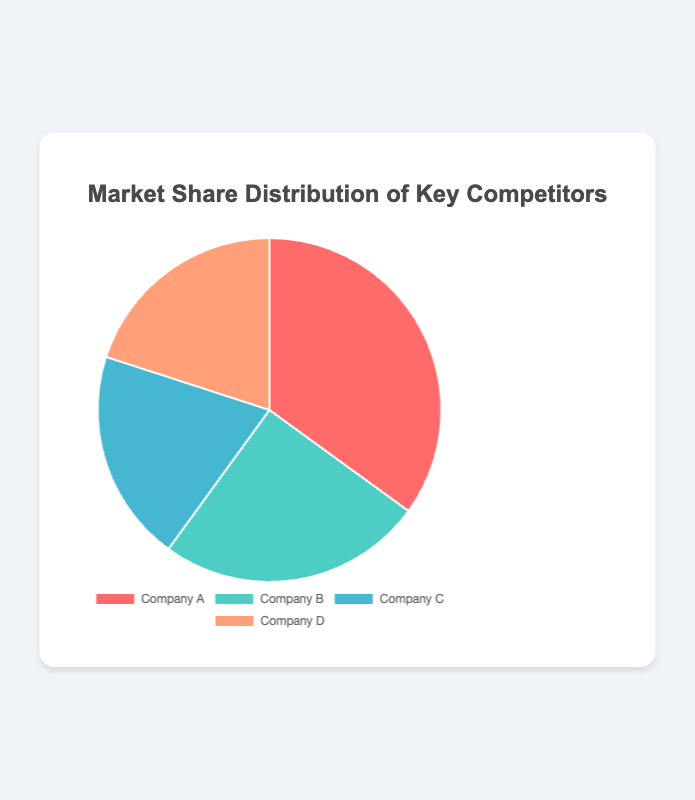what is the market share of Company A? By looking at the pie chart, we can see that the segment representing Company A is labeled with a market share percentage.
Answer: 35% Which company holds the smallest market share? Comparing the slices of the pie chart visually, we can see that Companies C and D have the smallest shares, both at 20%.
Answer: Company C and Company D What is the combined market share of Companies C and D? Adding the market shares of Companies C (20%) and D (20%) together to get the total. 20 + 20 = 40
Answer: 40% How does Company B's market share compare to Company A’s? By examining the pie chart, Company A has a 35% market share, while Company B has a 25% market share. Comparing these two, Company B's share is smaller.
Answer: Company A's share is larger by 10% Which company represents the largest segment of the pie? Looking at the visual representation and their labels, Company A, with a 35% share, occupies the largest segment.
Answer: Company A How much larger is Company A's market share compared to Company D's? Subtract Company D's market share (20%) from Company A's market share (35%). 35 - 20 = 15
Answer: 15% What is the average market share of all companies? To find the average, add up the market shares of all companies and divide by the number of companies. (35 + 25 + 20 + 20)/4 = 100/4 = 25
Answer: 25% If Company A and Company B merged, what would their combined market share be? Sum the market shares of Company A (35%) and Company B (25%). 35 + 25 = 60
Answer: 60% What color represents Company C? By referring to the visual attributes of the pie chart, the segment for Company C is in blue.
Answer: Blue Which two companies have equal market shares? By examining the labels on the pie chart, we can see that Company C and Company D both have a 20% market share.
Answer: Company C and Company D 